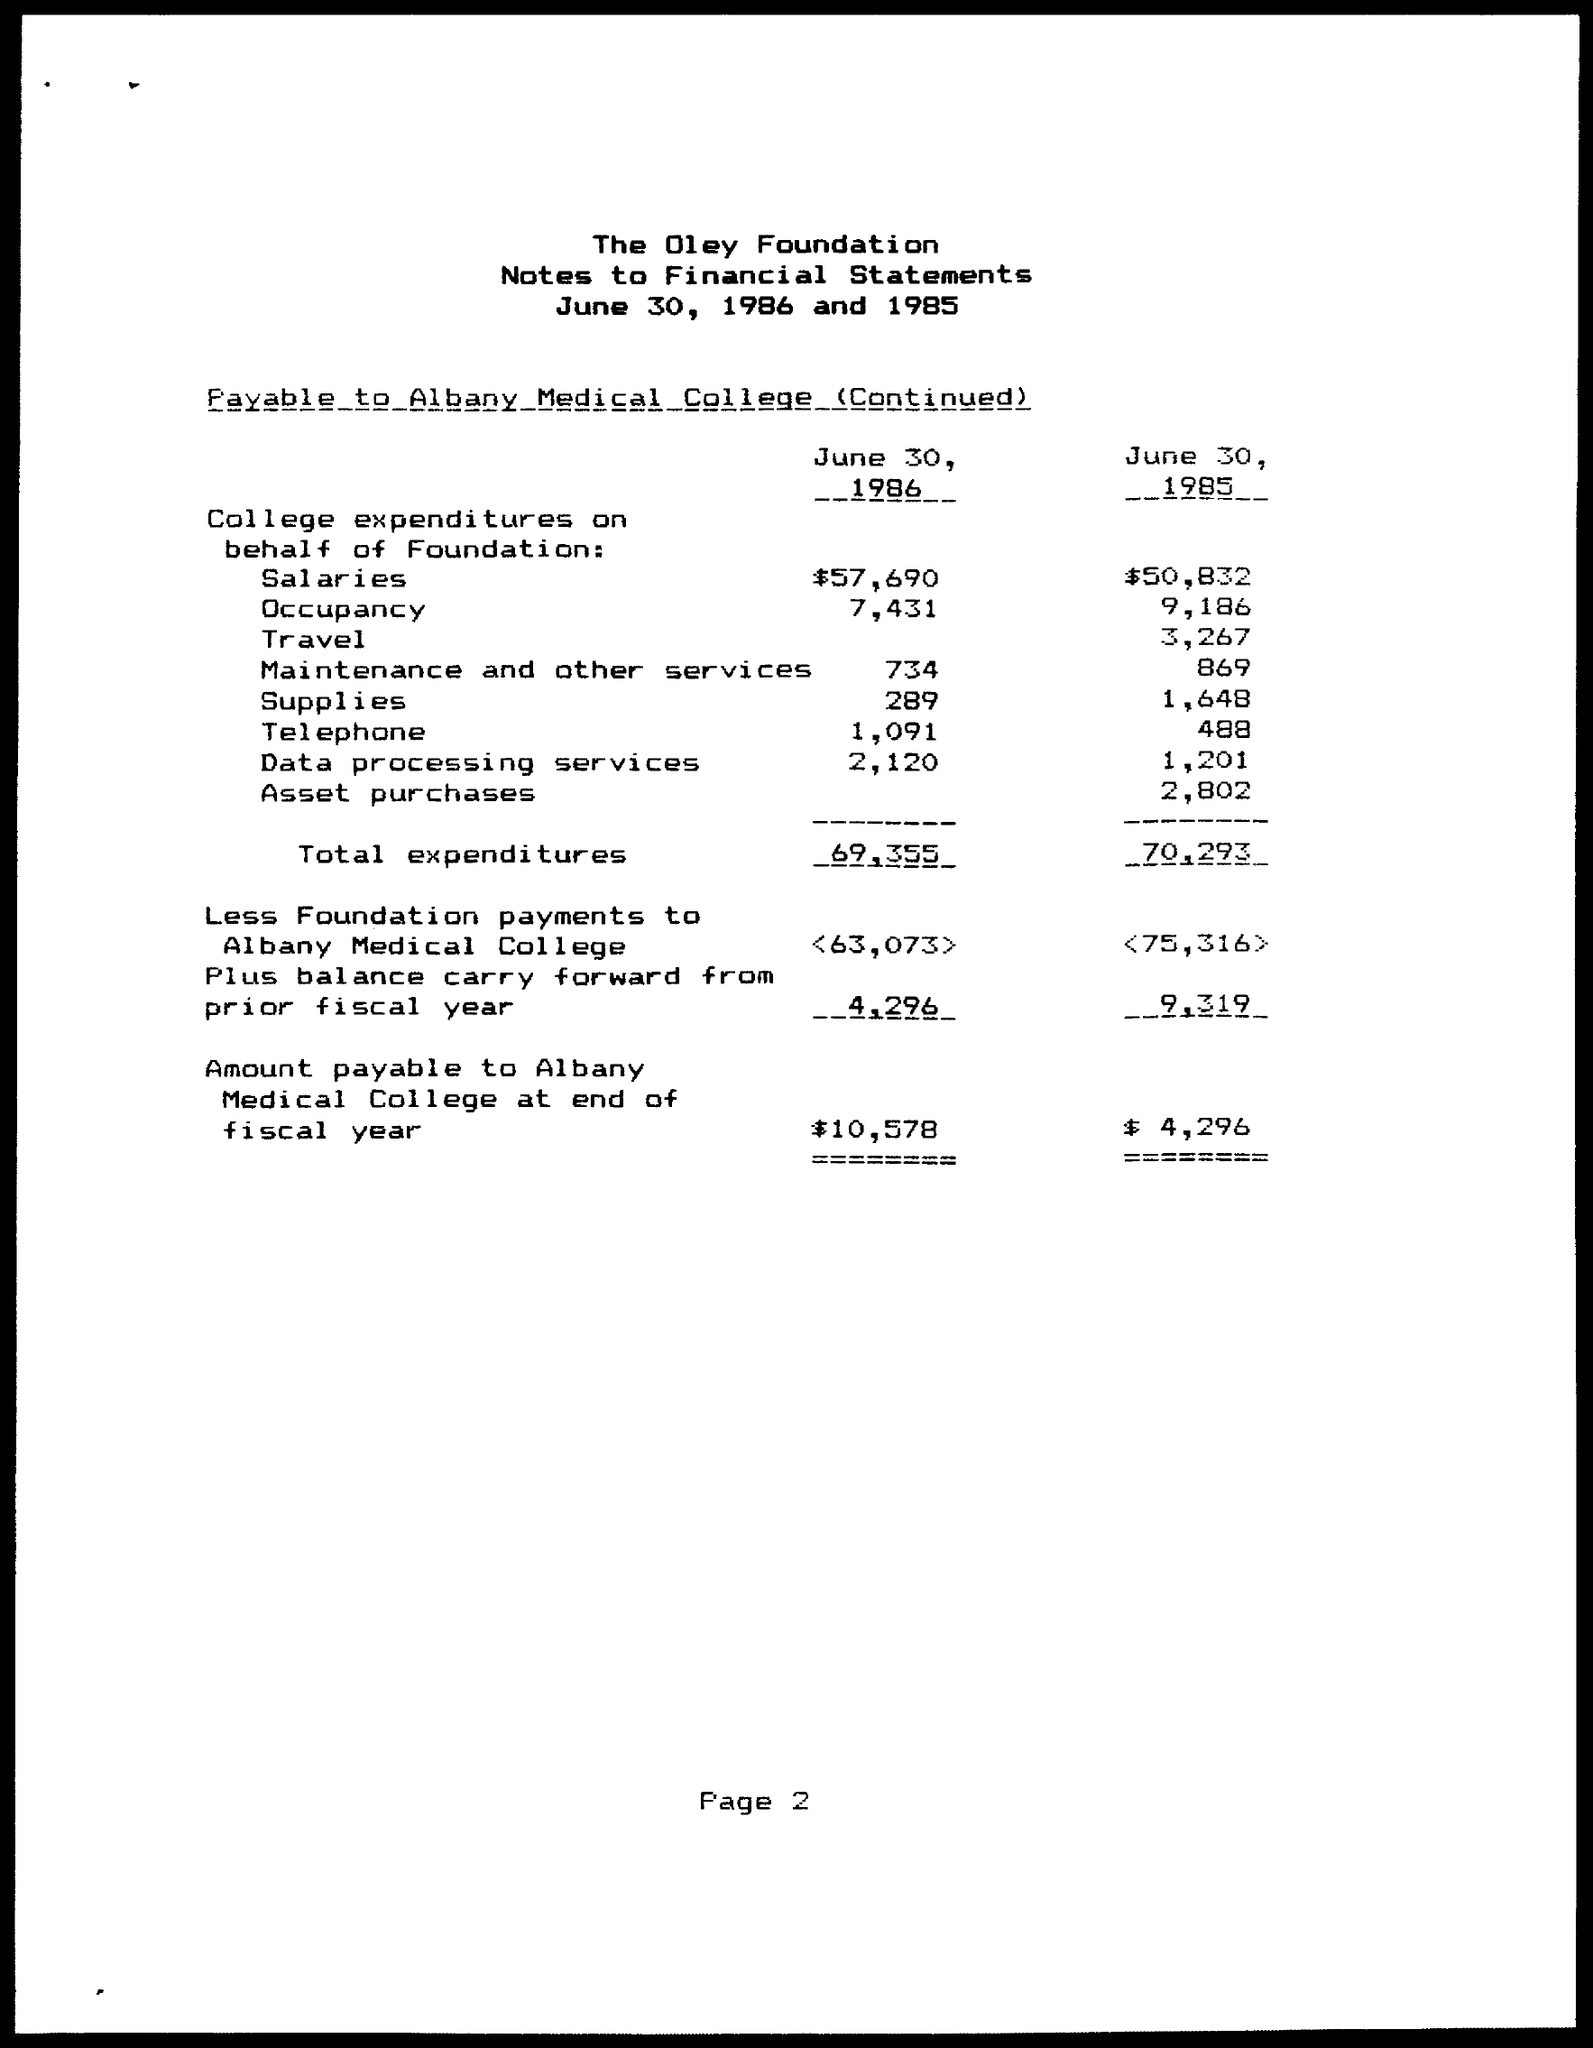What are the College expenditures on behalf of Foundation on Salaries on June 30, 1986?
Offer a very short reply. $57,690. What are the College expenditures on behalf of Foundation on Salaries on June 30, 1985?
Ensure brevity in your answer.  $50,832. What are the College expenditures on behalf of Foundation on Occupancy on June 30, 1986?
Keep it short and to the point. 7,431. What are the College expenditures on behalf of Foundation on Occupancy on June 30, 1985?
Your answer should be compact. 9,186. What are the College expenditures on behalf of Foundation on Travel on June 30, 1985?
Provide a succinct answer. 3,267. What are the College expenditures on behalf of Foundation on Maintenance and other services on June 30, 1986?
Make the answer very short. 734. What are the College expenditures on behalf of Foundation on Maintenance and other services on June 30, 1985?
Make the answer very short. 869. What are the College expenditures on behalf of Foundation on Supplies on June 30, 1986?
Offer a terse response. 289. What are the College expenditures on behalf of Foundation on Supplies on June 30, 1985?
Offer a terse response. 1,648. What are the Total expenditures for June 30, 1986?
Ensure brevity in your answer.  69,355. 